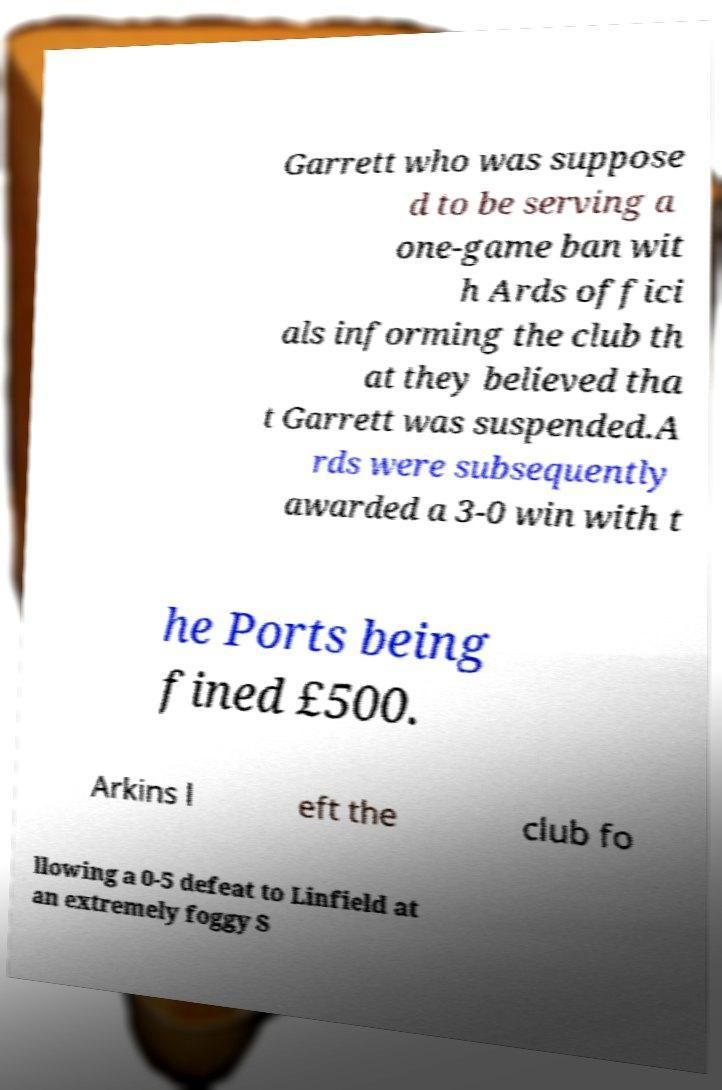There's text embedded in this image that I need extracted. Can you transcribe it verbatim? Garrett who was suppose d to be serving a one-game ban wit h Ards offici als informing the club th at they believed tha t Garrett was suspended.A rds were subsequently awarded a 3-0 win with t he Ports being fined £500. Arkins l eft the club fo llowing a 0-5 defeat to Linfield at an extremely foggy S 